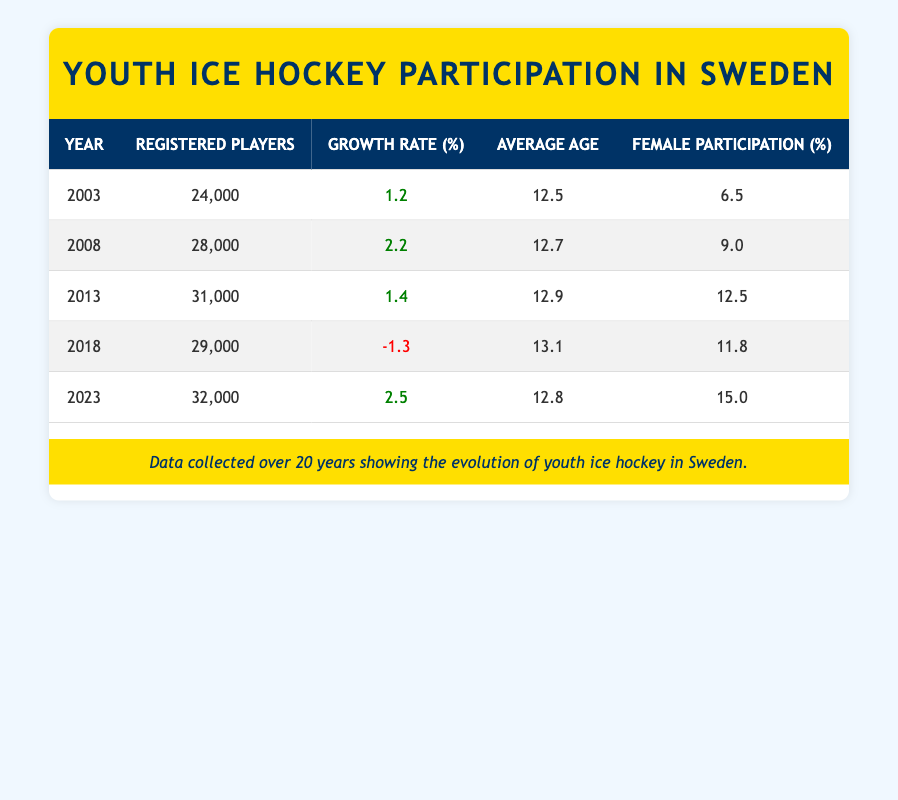What was the registered number of youth ice hockey players in 2003? According to the table, in the year 2003, the number of registered players was explicitly listed as 24,000.
Answer: 24,000 What was the growth rate of youth ice hockey participation from 2013 to 2018? The growth rate in 2013 was 1.4% and in 2018 it was -1.3%. The change from 2013 to 2018 is calculated as -1.3 - 1.4 = -2.7%. This indicates a decline in the growth rate overall during this time.
Answer: -2.7% Is female participation percentage higher in 2023 than in 2018? The female participation percentage in 2023 was 15.0% while in 2018 it was 11.8%. Since 15.0% is greater than 11.8%, the answer is yes.
Answer: Yes What was the average age of registered players in 2013? Looking at the table, the average age in 2013 is directly given as 12.9 years.
Answer: 12.9 What was the total number of registered players from 2003 to 2023? The total is calculated by adding the number of registered players for each year: 24,000 (2003) + 28,000 (2008) + 31,000 (2013) + 29,000 (2018) + 32,000 (2023) = 144,000.
Answer: 144,000 Was there a decline in the number of registered players between 2013 and 2018? In 2013, there were 31,000 registered players, whereas in 2018, it decreased to 29,000. This shows a decline of 2,000 players from 2013 to 2018.
Answer: Yes What is the average female participation percentage over the years shown in the table? The female participation percentages are 6.5%, 9.0%, 12.5%, 11.8%, and 15.0%. To find the average, add these percentages (6.5 + 9.0 + 12.5 + 11.8 + 15.0) and divide by 5. The total sum is 55.8%, so the average is 55.8% / 5 = 11.16%.
Answer: 11.16% Did the number of registered players see any decrease from 2008 to 2013? The number of registered players in 2008 was 28,000, and in 2013 it was 31,000. Since 31,000 is higher than 28,000, there was no decrease.
Answer: No What was the difference in registered players between the years 2003 and 2023? The number of registered players in 2003 was 24,000, and in 2023 it was 32,000. The difference is calculated as 32,000 - 24,000 = 8,000 players.
Answer: 8,000 